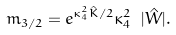Convert formula to latex. <formula><loc_0><loc_0><loc_500><loc_500>m _ { 3 / 2 } = e ^ { \kappa _ { 4 } ^ { 2 } \hat { K } / 2 } \kappa _ { 4 } ^ { 2 } \ | \hat { W } | .</formula> 